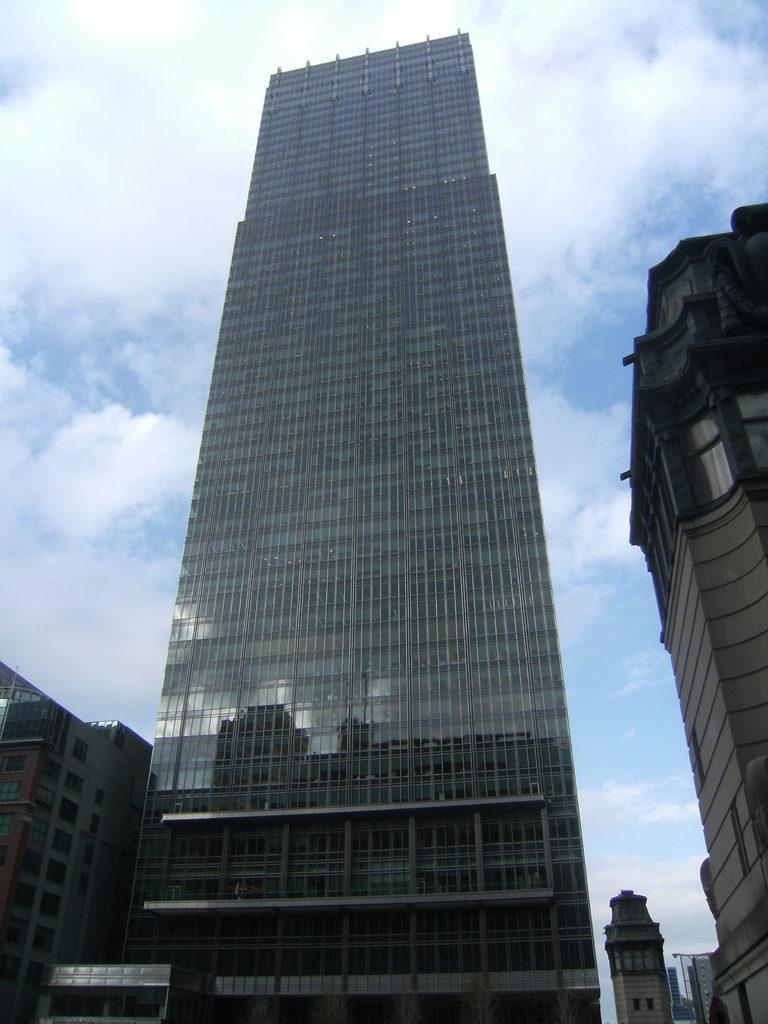Please provide a concise description of this image. There are buildings at the bottom of this image and the cloudy sky is in the background. 